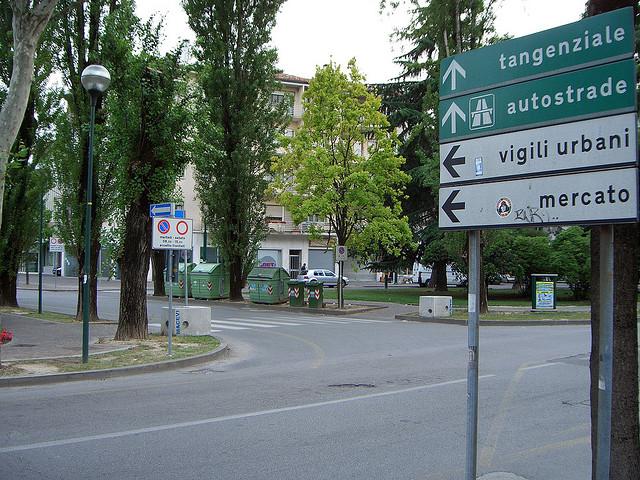Is this in the US?
Short answer required. No. What color is the street sign?
Write a very short answer. Green, white. What color is the sign?
Short answer required. Green. How many signs do you see in the picture?
Short answer required. 7. Where is the graffiti?
Short answer required. On sign. What language are these directional signs in?
Write a very short answer. Italian. Is this sign on the right way?
Keep it brief. Yes. Was this picture taken in Boston?
Quick response, please. No. Are the trees green?
Quick response, please. Yes. 